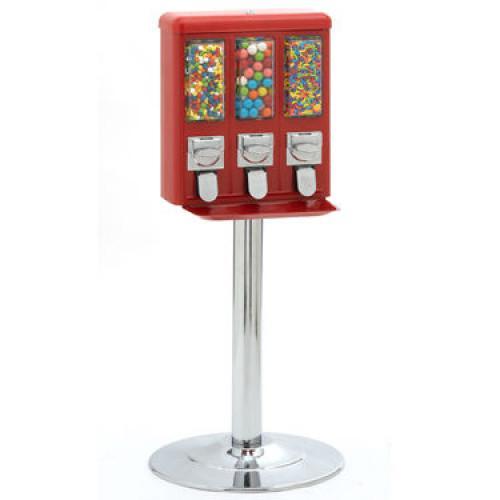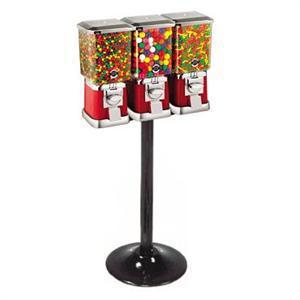The first image is the image on the left, the second image is the image on the right. Examine the images to the left and right. Is the description "An image shows just one vending machine, which has a trio of dispensers combined into one rectangular box shape." accurate? Answer yes or no. Yes. 